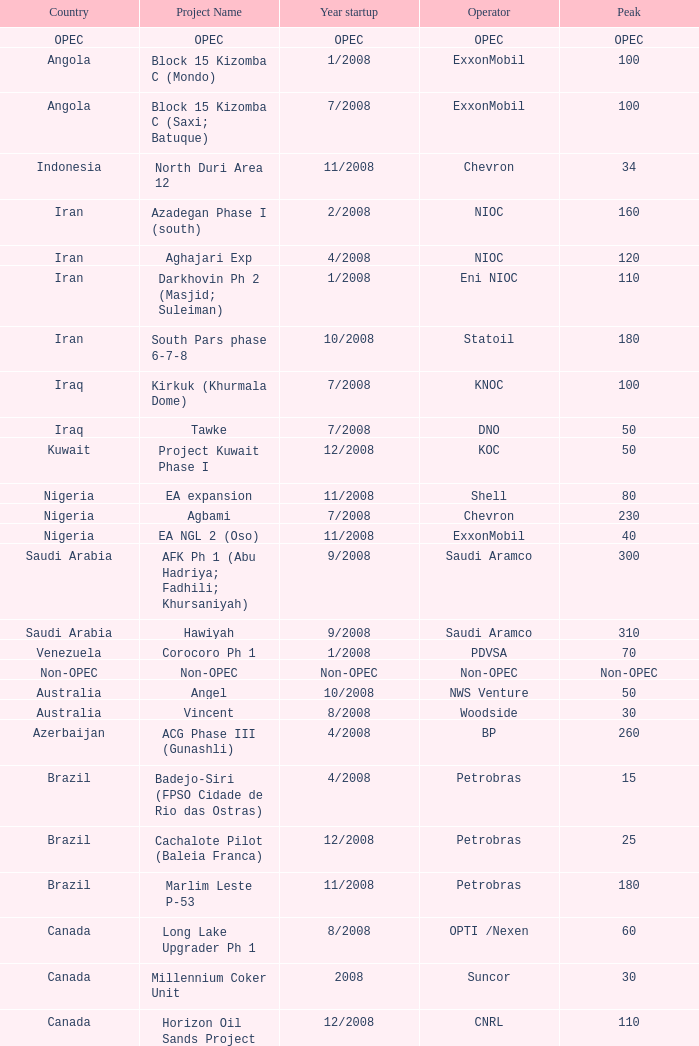What is the Peak with a Project Name that is talakan ph 1? 60.0. 